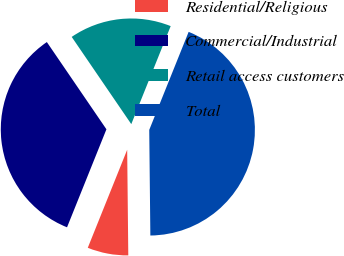Convert chart to OTSL. <chart><loc_0><loc_0><loc_500><loc_500><pie_chart><fcel>Residential/Religious<fcel>Commercial/Industrial<fcel>Retail access customers<fcel>Total<nl><fcel>6.25%<fcel>34.38%<fcel>15.62%<fcel>43.75%<nl></chart> 